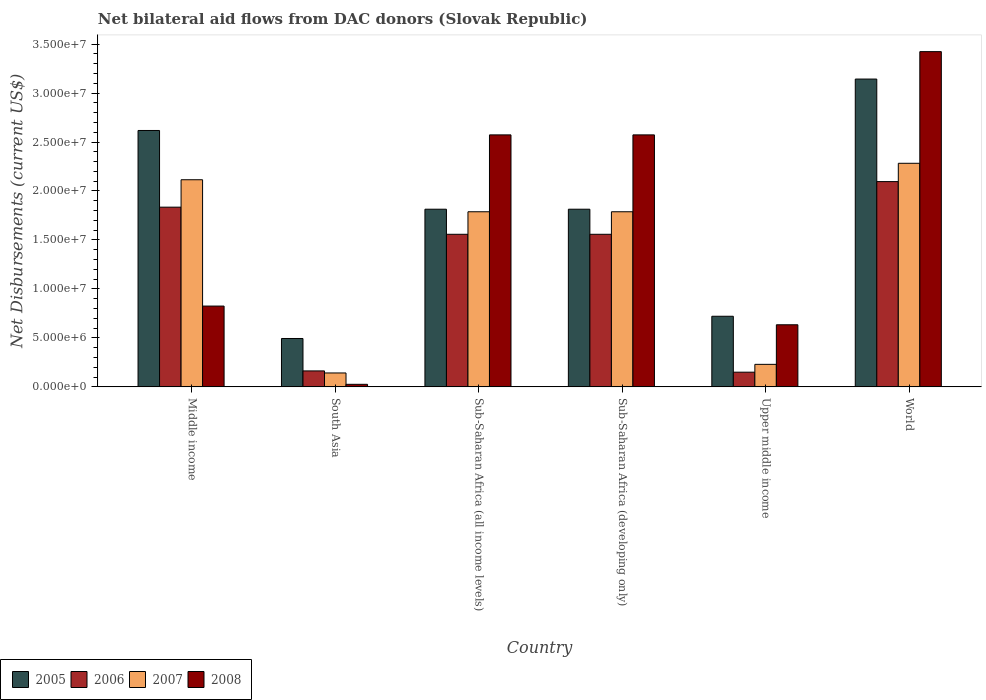How many different coloured bars are there?
Your answer should be compact. 4. How many groups of bars are there?
Your answer should be compact. 6. Are the number of bars per tick equal to the number of legend labels?
Provide a succinct answer. Yes. Are the number of bars on each tick of the X-axis equal?
Give a very brief answer. Yes. How many bars are there on the 1st tick from the left?
Your answer should be compact. 4. What is the label of the 5th group of bars from the left?
Keep it short and to the point. Upper middle income. In how many cases, is the number of bars for a given country not equal to the number of legend labels?
Ensure brevity in your answer.  0. What is the net bilateral aid flows in 2005 in Sub-Saharan Africa (all income levels)?
Keep it short and to the point. 1.81e+07. Across all countries, what is the maximum net bilateral aid flows in 2006?
Your answer should be compact. 2.10e+07. Across all countries, what is the minimum net bilateral aid flows in 2006?
Ensure brevity in your answer.  1.50e+06. In which country was the net bilateral aid flows in 2005 maximum?
Make the answer very short. World. What is the total net bilateral aid flows in 2007 in the graph?
Keep it short and to the point. 8.35e+07. What is the difference between the net bilateral aid flows in 2005 in South Asia and that in World?
Your response must be concise. -2.65e+07. What is the difference between the net bilateral aid flows in 2006 in Sub-Saharan Africa (all income levels) and the net bilateral aid flows in 2007 in World?
Make the answer very short. -7.25e+06. What is the average net bilateral aid flows in 2008 per country?
Offer a very short reply. 1.68e+07. What is the difference between the net bilateral aid flows of/in 2006 and net bilateral aid flows of/in 2005 in Middle income?
Keep it short and to the point. -7.83e+06. What is the ratio of the net bilateral aid flows in 2007 in Sub-Saharan Africa (all income levels) to that in Sub-Saharan Africa (developing only)?
Offer a very short reply. 1. Is the net bilateral aid flows in 2005 in Sub-Saharan Africa (all income levels) less than that in Upper middle income?
Keep it short and to the point. No. Is the difference between the net bilateral aid flows in 2006 in Sub-Saharan Africa (developing only) and Upper middle income greater than the difference between the net bilateral aid flows in 2005 in Sub-Saharan Africa (developing only) and Upper middle income?
Your response must be concise. Yes. What is the difference between the highest and the second highest net bilateral aid flows in 2006?
Keep it short and to the point. 5.38e+06. What is the difference between the highest and the lowest net bilateral aid flows in 2006?
Give a very brief answer. 1.95e+07. In how many countries, is the net bilateral aid flows in 2005 greater than the average net bilateral aid flows in 2005 taken over all countries?
Provide a short and direct response. 4. What does the 2nd bar from the left in Sub-Saharan Africa (developing only) represents?
Give a very brief answer. 2006. What does the 2nd bar from the right in Middle income represents?
Your response must be concise. 2007. Does the graph contain grids?
Your answer should be compact. No. Where does the legend appear in the graph?
Give a very brief answer. Bottom left. How many legend labels are there?
Provide a short and direct response. 4. How are the legend labels stacked?
Offer a terse response. Horizontal. What is the title of the graph?
Your response must be concise. Net bilateral aid flows from DAC donors (Slovak Republic). What is the label or title of the X-axis?
Your answer should be very brief. Country. What is the label or title of the Y-axis?
Offer a terse response. Net Disbursements (current US$). What is the Net Disbursements (current US$) in 2005 in Middle income?
Provide a succinct answer. 2.62e+07. What is the Net Disbursements (current US$) in 2006 in Middle income?
Your answer should be very brief. 1.84e+07. What is the Net Disbursements (current US$) of 2007 in Middle income?
Offer a terse response. 2.12e+07. What is the Net Disbursements (current US$) in 2008 in Middle income?
Give a very brief answer. 8.25e+06. What is the Net Disbursements (current US$) in 2005 in South Asia?
Your answer should be compact. 4.94e+06. What is the Net Disbursements (current US$) in 2006 in South Asia?
Offer a terse response. 1.63e+06. What is the Net Disbursements (current US$) of 2007 in South Asia?
Your response must be concise. 1.42e+06. What is the Net Disbursements (current US$) in 2008 in South Asia?
Provide a succinct answer. 2.60e+05. What is the Net Disbursements (current US$) of 2005 in Sub-Saharan Africa (all income levels)?
Your answer should be compact. 1.81e+07. What is the Net Disbursements (current US$) in 2006 in Sub-Saharan Africa (all income levels)?
Provide a succinct answer. 1.56e+07. What is the Net Disbursements (current US$) in 2007 in Sub-Saharan Africa (all income levels)?
Make the answer very short. 1.79e+07. What is the Net Disbursements (current US$) of 2008 in Sub-Saharan Africa (all income levels)?
Give a very brief answer. 2.57e+07. What is the Net Disbursements (current US$) of 2005 in Sub-Saharan Africa (developing only)?
Your answer should be compact. 1.81e+07. What is the Net Disbursements (current US$) of 2006 in Sub-Saharan Africa (developing only)?
Provide a succinct answer. 1.56e+07. What is the Net Disbursements (current US$) of 2007 in Sub-Saharan Africa (developing only)?
Make the answer very short. 1.79e+07. What is the Net Disbursements (current US$) in 2008 in Sub-Saharan Africa (developing only)?
Give a very brief answer. 2.57e+07. What is the Net Disbursements (current US$) of 2005 in Upper middle income?
Give a very brief answer. 7.21e+06. What is the Net Disbursements (current US$) in 2006 in Upper middle income?
Offer a very short reply. 1.50e+06. What is the Net Disbursements (current US$) of 2007 in Upper middle income?
Offer a very short reply. 2.30e+06. What is the Net Disbursements (current US$) of 2008 in Upper middle income?
Make the answer very short. 6.34e+06. What is the Net Disbursements (current US$) in 2005 in World?
Give a very brief answer. 3.14e+07. What is the Net Disbursements (current US$) in 2006 in World?
Offer a terse response. 2.10e+07. What is the Net Disbursements (current US$) in 2007 in World?
Keep it short and to the point. 2.28e+07. What is the Net Disbursements (current US$) of 2008 in World?
Provide a succinct answer. 3.42e+07. Across all countries, what is the maximum Net Disbursements (current US$) of 2005?
Provide a short and direct response. 3.14e+07. Across all countries, what is the maximum Net Disbursements (current US$) of 2006?
Make the answer very short. 2.10e+07. Across all countries, what is the maximum Net Disbursements (current US$) in 2007?
Your answer should be compact. 2.28e+07. Across all countries, what is the maximum Net Disbursements (current US$) of 2008?
Keep it short and to the point. 3.42e+07. Across all countries, what is the minimum Net Disbursements (current US$) in 2005?
Make the answer very short. 4.94e+06. Across all countries, what is the minimum Net Disbursements (current US$) in 2006?
Offer a terse response. 1.50e+06. Across all countries, what is the minimum Net Disbursements (current US$) in 2007?
Give a very brief answer. 1.42e+06. What is the total Net Disbursements (current US$) in 2005 in the graph?
Keep it short and to the point. 1.06e+08. What is the total Net Disbursements (current US$) of 2006 in the graph?
Your answer should be very brief. 7.36e+07. What is the total Net Disbursements (current US$) in 2007 in the graph?
Offer a terse response. 8.35e+07. What is the total Net Disbursements (current US$) in 2008 in the graph?
Your answer should be compact. 1.01e+08. What is the difference between the Net Disbursements (current US$) in 2005 in Middle income and that in South Asia?
Give a very brief answer. 2.12e+07. What is the difference between the Net Disbursements (current US$) in 2006 in Middle income and that in South Asia?
Keep it short and to the point. 1.67e+07. What is the difference between the Net Disbursements (current US$) of 2007 in Middle income and that in South Asia?
Keep it short and to the point. 1.97e+07. What is the difference between the Net Disbursements (current US$) of 2008 in Middle income and that in South Asia?
Make the answer very short. 7.99e+06. What is the difference between the Net Disbursements (current US$) in 2005 in Middle income and that in Sub-Saharan Africa (all income levels)?
Offer a terse response. 8.04e+06. What is the difference between the Net Disbursements (current US$) of 2006 in Middle income and that in Sub-Saharan Africa (all income levels)?
Offer a terse response. 2.77e+06. What is the difference between the Net Disbursements (current US$) in 2007 in Middle income and that in Sub-Saharan Africa (all income levels)?
Your answer should be very brief. 3.27e+06. What is the difference between the Net Disbursements (current US$) in 2008 in Middle income and that in Sub-Saharan Africa (all income levels)?
Your answer should be compact. -1.75e+07. What is the difference between the Net Disbursements (current US$) of 2005 in Middle income and that in Sub-Saharan Africa (developing only)?
Provide a succinct answer. 8.04e+06. What is the difference between the Net Disbursements (current US$) in 2006 in Middle income and that in Sub-Saharan Africa (developing only)?
Offer a terse response. 2.77e+06. What is the difference between the Net Disbursements (current US$) of 2007 in Middle income and that in Sub-Saharan Africa (developing only)?
Make the answer very short. 3.27e+06. What is the difference between the Net Disbursements (current US$) of 2008 in Middle income and that in Sub-Saharan Africa (developing only)?
Make the answer very short. -1.75e+07. What is the difference between the Net Disbursements (current US$) of 2005 in Middle income and that in Upper middle income?
Provide a short and direct response. 1.90e+07. What is the difference between the Net Disbursements (current US$) of 2006 in Middle income and that in Upper middle income?
Your response must be concise. 1.68e+07. What is the difference between the Net Disbursements (current US$) in 2007 in Middle income and that in Upper middle income?
Your answer should be compact. 1.88e+07. What is the difference between the Net Disbursements (current US$) in 2008 in Middle income and that in Upper middle income?
Offer a very short reply. 1.91e+06. What is the difference between the Net Disbursements (current US$) of 2005 in Middle income and that in World?
Offer a very short reply. -5.25e+06. What is the difference between the Net Disbursements (current US$) of 2006 in Middle income and that in World?
Keep it short and to the point. -2.61e+06. What is the difference between the Net Disbursements (current US$) in 2007 in Middle income and that in World?
Your response must be concise. -1.68e+06. What is the difference between the Net Disbursements (current US$) of 2008 in Middle income and that in World?
Your answer should be compact. -2.60e+07. What is the difference between the Net Disbursements (current US$) of 2005 in South Asia and that in Sub-Saharan Africa (all income levels)?
Your answer should be very brief. -1.32e+07. What is the difference between the Net Disbursements (current US$) of 2006 in South Asia and that in Sub-Saharan Africa (all income levels)?
Give a very brief answer. -1.40e+07. What is the difference between the Net Disbursements (current US$) in 2007 in South Asia and that in Sub-Saharan Africa (all income levels)?
Give a very brief answer. -1.65e+07. What is the difference between the Net Disbursements (current US$) in 2008 in South Asia and that in Sub-Saharan Africa (all income levels)?
Offer a terse response. -2.55e+07. What is the difference between the Net Disbursements (current US$) of 2005 in South Asia and that in Sub-Saharan Africa (developing only)?
Make the answer very short. -1.32e+07. What is the difference between the Net Disbursements (current US$) of 2006 in South Asia and that in Sub-Saharan Africa (developing only)?
Ensure brevity in your answer.  -1.40e+07. What is the difference between the Net Disbursements (current US$) in 2007 in South Asia and that in Sub-Saharan Africa (developing only)?
Make the answer very short. -1.65e+07. What is the difference between the Net Disbursements (current US$) of 2008 in South Asia and that in Sub-Saharan Africa (developing only)?
Your answer should be very brief. -2.55e+07. What is the difference between the Net Disbursements (current US$) of 2005 in South Asia and that in Upper middle income?
Your answer should be very brief. -2.27e+06. What is the difference between the Net Disbursements (current US$) of 2007 in South Asia and that in Upper middle income?
Your answer should be compact. -8.80e+05. What is the difference between the Net Disbursements (current US$) of 2008 in South Asia and that in Upper middle income?
Provide a short and direct response. -6.08e+06. What is the difference between the Net Disbursements (current US$) in 2005 in South Asia and that in World?
Your answer should be very brief. -2.65e+07. What is the difference between the Net Disbursements (current US$) in 2006 in South Asia and that in World?
Give a very brief answer. -1.93e+07. What is the difference between the Net Disbursements (current US$) in 2007 in South Asia and that in World?
Offer a terse response. -2.14e+07. What is the difference between the Net Disbursements (current US$) of 2008 in South Asia and that in World?
Give a very brief answer. -3.40e+07. What is the difference between the Net Disbursements (current US$) of 2005 in Sub-Saharan Africa (all income levels) and that in Sub-Saharan Africa (developing only)?
Make the answer very short. 0. What is the difference between the Net Disbursements (current US$) of 2005 in Sub-Saharan Africa (all income levels) and that in Upper middle income?
Offer a terse response. 1.09e+07. What is the difference between the Net Disbursements (current US$) in 2006 in Sub-Saharan Africa (all income levels) and that in Upper middle income?
Your answer should be compact. 1.41e+07. What is the difference between the Net Disbursements (current US$) in 2007 in Sub-Saharan Africa (all income levels) and that in Upper middle income?
Your answer should be compact. 1.56e+07. What is the difference between the Net Disbursements (current US$) in 2008 in Sub-Saharan Africa (all income levels) and that in Upper middle income?
Provide a succinct answer. 1.94e+07. What is the difference between the Net Disbursements (current US$) of 2005 in Sub-Saharan Africa (all income levels) and that in World?
Your answer should be very brief. -1.33e+07. What is the difference between the Net Disbursements (current US$) of 2006 in Sub-Saharan Africa (all income levels) and that in World?
Your answer should be compact. -5.38e+06. What is the difference between the Net Disbursements (current US$) in 2007 in Sub-Saharan Africa (all income levels) and that in World?
Offer a terse response. -4.95e+06. What is the difference between the Net Disbursements (current US$) in 2008 in Sub-Saharan Africa (all income levels) and that in World?
Offer a very short reply. -8.50e+06. What is the difference between the Net Disbursements (current US$) of 2005 in Sub-Saharan Africa (developing only) and that in Upper middle income?
Provide a short and direct response. 1.09e+07. What is the difference between the Net Disbursements (current US$) in 2006 in Sub-Saharan Africa (developing only) and that in Upper middle income?
Ensure brevity in your answer.  1.41e+07. What is the difference between the Net Disbursements (current US$) in 2007 in Sub-Saharan Africa (developing only) and that in Upper middle income?
Offer a very short reply. 1.56e+07. What is the difference between the Net Disbursements (current US$) of 2008 in Sub-Saharan Africa (developing only) and that in Upper middle income?
Provide a succinct answer. 1.94e+07. What is the difference between the Net Disbursements (current US$) of 2005 in Sub-Saharan Africa (developing only) and that in World?
Your response must be concise. -1.33e+07. What is the difference between the Net Disbursements (current US$) of 2006 in Sub-Saharan Africa (developing only) and that in World?
Keep it short and to the point. -5.38e+06. What is the difference between the Net Disbursements (current US$) of 2007 in Sub-Saharan Africa (developing only) and that in World?
Your answer should be very brief. -4.95e+06. What is the difference between the Net Disbursements (current US$) of 2008 in Sub-Saharan Africa (developing only) and that in World?
Offer a very short reply. -8.50e+06. What is the difference between the Net Disbursements (current US$) in 2005 in Upper middle income and that in World?
Your response must be concise. -2.42e+07. What is the difference between the Net Disbursements (current US$) of 2006 in Upper middle income and that in World?
Provide a short and direct response. -1.95e+07. What is the difference between the Net Disbursements (current US$) in 2007 in Upper middle income and that in World?
Provide a short and direct response. -2.05e+07. What is the difference between the Net Disbursements (current US$) in 2008 in Upper middle income and that in World?
Your answer should be very brief. -2.79e+07. What is the difference between the Net Disbursements (current US$) of 2005 in Middle income and the Net Disbursements (current US$) of 2006 in South Asia?
Provide a succinct answer. 2.46e+07. What is the difference between the Net Disbursements (current US$) in 2005 in Middle income and the Net Disbursements (current US$) in 2007 in South Asia?
Give a very brief answer. 2.48e+07. What is the difference between the Net Disbursements (current US$) of 2005 in Middle income and the Net Disbursements (current US$) of 2008 in South Asia?
Provide a succinct answer. 2.59e+07. What is the difference between the Net Disbursements (current US$) in 2006 in Middle income and the Net Disbursements (current US$) in 2007 in South Asia?
Give a very brief answer. 1.69e+07. What is the difference between the Net Disbursements (current US$) of 2006 in Middle income and the Net Disbursements (current US$) of 2008 in South Asia?
Provide a short and direct response. 1.81e+07. What is the difference between the Net Disbursements (current US$) in 2007 in Middle income and the Net Disbursements (current US$) in 2008 in South Asia?
Provide a succinct answer. 2.09e+07. What is the difference between the Net Disbursements (current US$) in 2005 in Middle income and the Net Disbursements (current US$) in 2006 in Sub-Saharan Africa (all income levels)?
Make the answer very short. 1.06e+07. What is the difference between the Net Disbursements (current US$) in 2005 in Middle income and the Net Disbursements (current US$) in 2007 in Sub-Saharan Africa (all income levels)?
Make the answer very short. 8.30e+06. What is the difference between the Net Disbursements (current US$) of 2006 in Middle income and the Net Disbursements (current US$) of 2007 in Sub-Saharan Africa (all income levels)?
Provide a succinct answer. 4.70e+05. What is the difference between the Net Disbursements (current US$) of 2006 in Middle income and the Net Disbursements (current US$) of 2008 in Sub-Saharan Africa (all income levels)?
Your response must be concise. -7.38e+06. What is the difference between the Net Disbursements (current US$) of 2007 in Middle income and the Net Disbursements (current US$) of 2008 in Sub-Saharan Africa (all income levels)?
Make the answer very short. -4.58e+06. What is the difference between the Net Disbursements (current US$) in 2005 in Middle income and the Net Disbursements (current US$) in 2006 in Sub-Saharan Africa (developing only)?
Make the answer very short. 1.06e+07. What is the difference between the Net Disbursements (current US$) of 2005 in Middle income and the Net Disbursements (current US$) of 2007 in Sub-Saharan Africa (developing only)?
Your answer should be compact. 8.30e+06. What is the difference between the Net Disbursements (current US$) in 2005 in Middle income and the Net Disbursements (current US$) in 2008 in Sub-Saharan Africa (developing only)?
Ensure brevity in your answer.  4.50e+05. What is the difference between the Net Disbursements (current US$) of 2006 in Middle income and the Net Disbursements (current US$) of 2008 in Sub-Saharan Africa (developing only)?
Keep it short and to the point. -7.38e+06. What is the difference between the Net Disbursements (current US$) in 2007 in Middle income and the Net Disbursements (current US$) in 2008 in Sub-Saharan Africa (developing only)?
Offer a terse response. -4.58e+06. What is the difference between the Net Disbursements (current US$) of 2005 in Middle income and the Net Disbursements (current US$) of 2006 in Upper middle income?
Keep it short and to the point. 2.47e+07. What is the difference between the Net Disbursements (current US$) in 2005 in Middle income and the Net Disbursements (current US$) in 2007 in Upper middle income?
Keep it short and to the point. 2.39e+07. What is the difference between the Net Disbursements (current US$) of 2005 in Middle income and the Net Disbursements (current US$) of 2008 in Upper middle income?
Ensure brevity in your answer.  1.98e+07. What is the difference between the Net Disbursements (current US$) in 2006 in Middle income and the Net Disbursements (current US$) in 2007 in Upper middle income?
Your answer should be compact. 1.60e+07. What is the difference between the Net Disbursements (current US$) in 2006 in Middle income and the Net Disbursements (current US$) in 2008 in Upper middle income?
Offer a terse response. 1.20e+07. What is the difference between the Net Disbursements (current US$) in 2007 in Middle income and the Net Disbursements (current US$) in 2008 in Upper middle income?
Ensure brevity in your answer.  1.48e+07. What is the difference between the Net Disbursements (current US$) in 2005 in Middle income and the Net Disbursements (current US$) in 2006 in World?
Offer a very short reply. 5.22e+06. What is the difference between the Net Disbursements (current US$) of 2005 in Middle income and the Net Disbursements (current US$) of 2007 in World?
Give a very brief answer. 3.35e+06. What is the difference between the Net Disbursements (current US$) in 2005 in Middle income and the Net Disbursements (current US$) in 2008 in World?
Ensure brevity in your answer.  -8.05e+06. What is the difference between the Net Disbursements (current US$) in 2006 in Middle income and the Net Disbursements (current US$) in 2007 in World?
Offer a very short reply. -4.48e+06. What is the difference between the Net Disbursements (current US$) in 2006 in Middle income and the Net Disbursements (current US$) in 2008 in World?
Keep it short and to the point. -1.59e+07. What is the difference between the Net Disbursements (current US$) of 2007 in Middle income and the Net Disbursements (current US$) of 2008 in World?
Offer a very short reply. -1.31e+07. What is the difference between the Net Disbursements (current US$) of 2005 in South Asia and the Net Disbursements (current US$) of 2006 in Sub-Saharan Africa (all income levels)?
Your response must be concise. -1.06e+07. What is the difference between the Net Disbursements (current US$) in 2005 in South Asia and the Net Disbursements (current US$) in 2007 in Sub-Saharan Africa (all income levels)?
Make the answer very short. -1.29e+07. What is the difference between the Net Disbursements (current US$) of 2005 in South Asia and the Net Disbursements (current US$) of 2008 in Sub-Saharan Africa (all income levels)?
Your answer should be very brief. -2.08e+07. What is the difference between the Net Disbursements (current US$) of 2006 in South Asia and the Net Disbursements (current US$) of 2007 in Sub-Saharan Africa (all income levels)?
Make the answer very short. -1.62e+07. What is the difference between the Net Disbursements (current US$) in 2006 in South Asia and the Net Disbursements (current US$) in 2008 in Sub-Saharan Africa (all income levels)?
Provide a succinct answer. -2.41e+07. What is the difference between the Net Disbursements (current US$) of 2007 in South Asia and the Net Disbursements (current US$) of 2008 in Sub-Saharan Africa (all income levels)?
Provide a short and direct response. -2.43e+07. What is the difference between the Net Disbursements (current US$) in 2005 in South Asia and the Net Disbursements (current US$) in 2006 in Sub-Saharan Africa (developing only)?
Keep it short and to the point. -1.06e+07. What is the difference between the Net Disbursements (current US$) of 2005 in South Asia and the Net Disbursements (current US$) of 2007 in Sub-Saharan Africa (developing only)?
Your answer should be very brief. -1.29e+07. What is the difference between the Net Disbursements (current US$) of 2005 in South Asia and the Net Disbursements (current US$) of 2008 in Sub-Saharan Africa (developing only)?
Provide a short and direct response. -2.08e+07. What is the difference between the Net Disbursements (current US$) of 2006 in South Asia and the Net Disbursements (current US$) of 2007 in Sub-Saharan Africa (developing only)?
Provide a succinct answer. -1.62e+07. What is the difference between the Net Disbursements (current US$) of 2006 in South Asia and the Net Disbursements (current US$) of 2008 in Sub-Saharan Africa (developing only)?
Keep it short and to the point. -2.41e+07. What is the difference between the Net Disbursements (current US$) in 2007 in South Asia and the Net Disbursements (current US$) in 2008 in Sub-Saharan Africa (developing only)?
Make the answer very short. -2.43e+07. What is the difference between the Net Disbursements (current US$) of 2005 in South Asia and the Net Disbursements (current US$) of 2006 in Upper middle income?
Give a very brief answer. 3.44e+06. What is the difference between the Net Disbursements (current US$) in 2005 in South Asia and the Net Disbursements (current US$) in 2007 in Upper middle income?
Your answer should be compact. 2.64e+06. What is the difference between the Net Disbursements (current US$) in 2005 in South Asia and the Net Disbursements (current US$) in 2008 in Upper middle income?
Your response must be concise. -1.40e+06. What is the difference between the Net Disbursements (current US$) in 2006 in South Asia and the Net Disbursements (current US$) in 2007 in Upper middle income?
Provide a succinct answer. -6.70e+05. What is the difference between the Net Disbursements (current US$) in 2006 in South Asia and the Net Disbursements (current US$) in 2008 in Upper middle income?
Offer a very short reply. -4.71e+06. What is the difference between the Net Disbursements (current US$) of 2007 in South Asia and the Net Disbursements (current US$) of 2008 in Upper middle income?
Keep it short and to the point. -4.92e+06. What is the difference between the Net Disbursements (current US$) in 2005 in South Asia and the Net Disbursements (current US$) in 2006 in World?
Give a very brief answer. -1.60e+07. What is the difference between the Net Disbursements (current US$) in 2005 in South Asia and the Net Disbursements (current US$) in 2007 in World?
Make the answer very short. -1.79e+07. What is the difference between the Net Disbursements (current US$) of 2005 in South Asia and the Net Disbursements (current US$) of 2008 in World?
Your answer should be very brief. -2.93e+07. What is the difference between the Net Disbursements (current US$) in 2006 in South Asia and the Net Disbursements (current US$) in 2007 in World?
Make the answer very short. -2.12e+07. What is the difference between the Net Disbursements (current US$) of 2006 in South Asia and the Net Disbursements (current US$) of 2008 in World?
Offer a very short reply. -3.26e+07. What is the difference between the Net Disbursements (current US$) of 2007 in South Asia and the Net Disbursements (current US$) of 2008 in World?
Give a very brief answer. -3.28e+07. What is the difference between the Net Disbursements (current US$) of 2005 in Sub-Saharan Africa (all income levels) and the Net Disbursements (current US$) of 2006 in Sub-Saharan Africa (developing only)?
Offer a terse response. 2.56e+06. What is the difference between the Net Disbursements (current US$) in 2005 in Sub-Saharan Africa (all income levels) and the Net Disbursements (current US$) in 2008 in Sub-Saharan Africa (developing only)?
Keep it short and to the point. -7.59e+06. What is the difference between the Net Disbursements (current US$) of 2006 in Sub-Saharan Africa (all income levels) and the Net Disbursements (current US$) of 2007 in Sub-Saharan Africa (developing only)?
Offer a terse response. -2.30e+06. What is the difference between the Net Disbursements (current US$) of 2006 in Sub-Saharan Africa (all income levels) and the Net Disbursements (current US$) of 2008 in Sub-Saharan Africa (developing only)?
Keep it short and to the point. -1.02e+07. What is the difference between the Net Disbursements (current US$) in 2007 in Sub-Saharan Africa (all income levels) and the Net Disbursements (current US$) in 2008 in Sub-Saharan Africa (developing only)?
Offer a very short reply. -7.85e+06. What is the difference between the Net Disbursements (current US$) in 2005 in Sub-Saharan Africa (all income levels) and the Net Disbursements (current US$) in 2006 in Upper middle income?
Make the answer very short. 1.66e+07. What is the difference between the Net Disbursements (current US$) in 2005 in Sub-Saharan Africa (all income levels) and the Net Disbursements (current US$) in 2007 in Upper middle income?
Provide a succinct answer. 1.58e+07. What is the difference between the Net Disbursements (current US$) in 2005 in Sub-Saharan Africa (all income levels) and the Net Disbursements (current US$) in 2008 in Upper middle income?
Provide a short and direct response. 1.18e+07. What is the difference between the Net Disbursements (current US$) of 2006 in Sub-Saharan Africa (all income levels) and the Net Disbursements (current US$) of 2007 in Upper middle income?
Your response must be concise. 1.33e+07. What is the difference between the Net Disbursements (current US$) of 2006 in Sub-Saharan Africa (all income levels) and the Net Disbursements (current US$) of 2008 in Upper middle income?
Your response must be concise. 9.24e+06. What is the difference between the Net Disbursements (current US$) of 2007 in Sub-Saharan Africa (all income levels) and the Net Disbursements (current US$) of 2008 in Upper middle income?
Your response must be concise. 1.15e+07. What is the difference between the Net Disbursements (current US$) in 2005 in Sub-Saharan Africa (all income levels) and the Net Disbursements (current US$) in 2006 in World?
Make the answer very short. -2.82e+06. What is the difference between the Net Disbursements (current US$) of 2005 in Sub-Saharan Africa (all income levels) and the Net Disbursements (current US$) of 2007 in World?
Offer a very short reply. -4.69e+06. What is the difference between the Net Disbursements (current US$) in 2005 in Sub-Saharan Africa (all income levels) and the Net Disbursements (current US$) in 2008 in World?
Make the answer very short. -1.61e+07. What is the difference between the Net Disbursements (current US$) of 2006 in Sub-Saharan Africa (all income levels) and the Net Disbursements (current US$) of 2007 in World?
Keep it short and to the point. -7.25e+06. What is the difference between the Net Disbursements (current US$) of 2006 in Sub-Saharan Africa (all income levels) and the Net Disbursements (current US$) of 2008 in World?
Provide a short and direct response. -1.86e+07. What is the difference between the Net Disbursements (current US$) in 2007 in Sub-Saharan Africa (all income levels) and the Net Disbursements (current US$) in 2008 in World?
Your response must be concise. -1.64e+07. What is the difference between the Net Disbursements (current US$) in 2005 in Sub-Saharan Africa (developing only) and the Net Disbursements (current US$) in 2006 in Upper middle income?
Your response must be concise. 1.66e+07. What is the difference between the Net Disbursements (current US$) of 2005 in Sub-Saharan Africa (developing only) and the Net Disbursements (current US$) of 2007 in Upper middle income?
Make the answer very short. 1.58e+07. What is the difference between the Net Disbursements (current US$) of 2005 in Sub-Saharan Africa (developing only) and the Net Disbursements (current US$) of 2008 in Upper middle income?
Offer a very short reply. 1.18e+07. What is the difference between the Net Disbursements (current US$) in 2006 in Sub-Saharan Africa (developing only) and the Net Disbursements (current US$) in 2007 in Upper middle income?
Make the answer very short. 1.33e+07. What is the difference between the Net Disbursements (current US$) in 2006 in Sub-Saharan Africa (developing only) and the Net Disbursements (current US$) in 2008 in Upper middle income?
Provide a succinct answer. 9.24e+06. What is the difference between the Net Disbursements (current US$) of 2007 in Sub-Saharan Africa (developing only) and the Net Disbursements (current US$) of 2008 in Upper middle income?
Your response must be concise. 1.15e+07. What is the difference between the Net Disbursements (current US$) of 2005 in Sub-Saharan Africa (developing only) and the Net Disbursements (current US$) of 2006 in World?
Your answer should be very brief. -2.82e+06. What is the difference between the Net Disbursements (current US$) in 2005 in Sub-Saharan Africa (developing only) and the Net Disbursements (current US$) in 2007 in World?
Your answer should be compact. -4.69e+06. What is the difference between the Net Disbursements (current US$) in 2005 in Sub-Saharan Africa (developing only) and the Net Disbursements (current US$) in 2008 in World?
Offer a terse response. -1.61e+07. What is the difference between the Net Disbursements (current US$) in 2006 in Sub-Saharan Africa (developing only) and the Net Disbursements (current US$) in 2007 in World?
Keep it short and to the point. -7.25e+06. What is the difference between the Net Disbursements (current US$) in 2006 in Sub-Saharan Africa (developing only) and the Net Disbursements (current US$) in 2008 in World?
Provide a succinct answer. -1.86e+07. What is the difference between the Net Disbursements (current US$) in 2007 in Sub-Saharan Africa (developing only) and the Net Disbursements (current US$) in 2008 in World?
Provide a short and direct response. -1.64e+07. What is the difference between the Net Disbursements (current US$) of 2005 in Upper middle income and the Net Disbursements (current US$) of 2006 in World?
Your answer should be very brief. -1.38e+07. What is the difference between the Net Disbursements (current US$) of 2005 in Upper middle income and the Net Disbursements (current US$) of 2007 in World?
Your answer should be compact. -1.56e+07. What is the difference between the Net Disbursements (current US$) in 2005 in Upper middle income and the Net Disbursements (current US$) in 2008 in World?
Your answer should be compact. -2.70e+07. What is the difference between the Net Disbursements (current US$) of 2006 in Upper middle income and the Net Disbursements (current US$) of 2007 in World?
Your answer should be very brief. -2.13e+07. What is the difference between the Net Disbursements (current US$) of 2006 in Upper middle income and the Net Disbursements (current US$) of 2008 in World?
Offer a terse response. -3.27e+07. What is the difference between the Net Disbursements (current US$) in 2007 in Upper middle income and the Net Disbursements (current US$) in 2008 in World?
Offer a very short reply. -3.19e+07. What is the average Net Disbursements (current US$) in 2005 per country?
Make the answer very short. 1.77e+07. What is the average Net Disbursements (current US$) in 2006 per country?
Offer a very short reply. 1.23e+07. What is the average Net Disbursements (current US$) of 2007 per country?
Your answer should be compact. 1.39e+07. What is the average Net Disbursements (current US$) in 2008 per country?
Ensure brevity in your answer.  1.68e+07. What is the difference between the Net Disbursements (current US$) in 2005 and Net Disbursements (current US$) in 2006 in Middle income?
Offer a terse response. 7.83e+06. What is the difference between the Net Disbursements (current US$) in 2005 and Net Disbursements (current US$) in 2007 in Middle income?
Keep it short and to the point. 5.03e+06. What is the difference between the Net Disbursements (current US$) in 2005 and Net Disbursements (current US$) in 2008 in Middle income?
Give a very brief answer. 1.79e+07. What is the difference between the Net Disbursements (current US$) in 2006 and Net Disbursements (current US$) in 2007 in Middle income?
Provide a succinct answer. -2.80e+06. What is the difference between the Net Disbursements (current US$) in 2006 and Net Disbursements (current US$) in 2008 in Middle income?
Offer a terse response. 1.01e+07. What is the difference between the Net Disbursements (current US$) in 2007 and Net Disbursements (current US$) in 2008 in Middle income?
Your response must be concise. 1.29e+07. What is the difference between the Net Disbursements (current US$) in 2005 and Net Disbursements (current US$) in 2006 in South Asia?
Provide a short and direct response. 3.31e+06. What is the difference between the Net Disbursements (current US$) of 2005 and Net Disbursements (current US$) of 2007 in South Asia?
Your answer should be very brief. 3.52e+06. What is the difference between the Net Disbursements (current US$) in 2005 and Net Disbursements (current US$) in 2008 in South Asia?
Provide a succinct answer. 4.68e+06. What is the difference between the Net Disbursements (current US$) of 2006 and Net Disbursements (current US$) of 2007 in South Asia?
Offer a very short reply. 2.10e+05. What is the difference between the Net Disbursements (current US$) in 2006 and Net Disbursements (current US$) in 2008 in South Asia?
Provide a succinct answer. 1.37e+06. What is the difference between the Net Disbursements (current US$) of 2007 and Net Disbursements (current US$) of 2008 in South Asia?
Keep it short and to the point. 1.16e+06. What is the difference between the Net Disbursements (current US$) in 2005 and Net Disbursements (current US$) in 2006 in Sub-Saharan Africa (all income levels)?
Your answer should be very brief. 2.56e+06. What is the difference between the Net Disbursements (current US$) of 2005 and Net Disbursements (current US$) of 2007 in Sub-Saharan Africa (all income levels)?
Provide a short and direct response. 2.60e+05. What is the difference between the Net Disbursements (current US$) of 2005 and Net Disbursements (current US$) of 2008 in Sub-Saharan Africa (all income levels)?
Your answer should be compact. -7.59e+06. What is the difference between the Net Disbursements (current US$) in 2006 and Net Disbursements (current US$) in 2007 in Sub-Saharan Africa (all income levels)?
Make the answer very short. -2.30e+06. What is the difference between the Net Disbursements (current US$) in 2006 and Net Disbursements (current US$) in 2008 in Sub-Saharan Africa (all income levels)?
Give a very brief answer. -1.02e+07. What is the difference between the Net Disbursements (current US$) of 2007 and Net Disbursements (current US$) of 2008 in Sub-Saharan Africa (all income levels)?
Offer a very short reply. -7.85e+06. What is the difference between the Net Disbursements (current US$) in 2005 and Net Disbursements (current US$) in 2006 in Sub-Saharan Africa (developing only)?
Offer a terse response. 2.56e+06. What is the difference between the Net Disbursements (current US$) in 2005 and Net Disbursements (current US$) in 2007 in Sub-Saharan Africa (developing only)?
Offer a terse response. 2.60e+05. What is the difference between the Net Disbursements (current US$) of 2005 and Net Disbursements (current US$) of 2008 in Sub-Saharan Africa (developing only)?
Keep it short and to the point. -7.59e+06. What is the difference between the Net Disbursements (current US$) in 2006 and Net Disbursements (current US$) in 2007 in Sub-Saharan Africa (developing only)?
Make the answer very short. -2.30e+06. What is the difference between the Net Disbursements (current US$) in 2006 and Net Disbursements (current US$) in 2008 in Sub-Saharan Africa (developing only)?
Give a very brief answer. -1.02e+07. What is the difference between the Net Disbursements (current US$) in 2007 and Net Disbursements (current US$) in 2008 in Sub-Saharan Africa (developing only)?
Make the answer very short. -7.85e+06. What is the difference between the Net Disbursements (current US$) of 2005 and Net Disbursements (current US$) of 2006 in Upper middle income?
Make the answer very short. 5.71e+06. What is the difference between the Net Disbursements (current US$) in 2005 and Net Disbursements (current US$) in 2007 in Upper middle income?
Your response must be concise. 4.91e+06. What is the difference between the Net Disbursements (current US$) in 2005 and Net Disbursements (current US$) in 2008 in Upper middle income?
Your answer should be very brief. 8.70e+05. What is the difference between the Net Disbursements (current US$) of 2006 and Net Disbursements (current US$) of 2007 in Upper middle income?
Offer a terse response. -8.00e+05. What is the difference between the Net Disbursements (current US$) in 2006 and Net Disbursements (current US$) in 2008 in Upper middle income?
Provide a short and direct response. -4.84e+06. What is the difference between the Net Disbursements (current US$) of 2007 and Net Disbursements (current US$) of 2008 in Upper middle income?
Keep it short and to the point. -4.04e+06. What is the difference between the Net Disbursements (current US$) of 2005 and Net Disbursements (current US$) of 2006 in World?
Ensure brevity in your answer.  1.05e+07. What is the difference between the Net Disbursements (current US$) of 2005 and Net Disbursements (current US$) of 2007 in World?
Ensure brevity in your answer.  8.60e+06. What is the difference between the Net Disbursements (current US$) of 2005 and Net Disbursements (current US$) of 2008 in World?
Provide a succinct answer. -2.80e+06. What is the difference between the Net Disbursements (current US$) in 2006 and Net Disbursements (current US$) in 2007 in World?
Provide a succinct answer. -1.87e+06. What is the difference between the Net Disbursements (current US$) of 2006 and Net Disbursements (current US$) of 2008 in World?
Your answer should be very brief. -1.33e+07. What is the difference between the Net Disbursements (current US$) of 2007 and Net Disbursements (current US$) of 2008 in World?
Ensure brevity in your answer.  -1.14e+07. What is the ratio of the Net Disbursements (current US$) in 2005 in Middle income to that in South Asia?
Ensure brevity in your answer.  5.3. What is the ratio of the Net Disbursements (current US$) of 2006 in Middle income to that in South Asia?
Give a very brief answer. 11.26. What is the ratio of the Net Disbursements (current US$) of 2007 in Middle income to that in South Asia?
Keep it short and to the point. 14.89. What is the ratio of the Net Disbursements (current US$) of 2008 in Middle income to that in South Asia?
Provide a succinct answer. 31.73. What is the ratio of the Net Disbursements (current US$) in 2005 in Middle income to that in Sub-Saharan Africa (all income levels)?
Provide a short and direct response. 1.44. What is the ratio of the Net Disbursements (current US$) in 2006 in Middle income to that in Sub-Saharan Africa (all income levels)?
Provide a short and direct response. 1.18. What is the ratio of the Net Disbursements (current US$) in 2007 in Middle income to that in Sub-Saharan Africa (all income levels)?
Give a very brief answer. 1.18. What is the ratio of the Net Disbursements (current US$) of 2008 in Middle income to that in Sub-Saharan Africa (all income levels)?
Offer a very short reply. 0.32. What is the ratio of the Net Disbursements (current US$) of 2005 in Middle income to that in Sub-Saharan Africa (developing only)?
Your response must be concise. 1.44. What is the ratio of the Net Disbursements (current US$) of 2006 in Middle income to that in Sub-Saharan Africa (developing only)?
Your answer should be compact. 1.18. What is the ratio of the Net Disbursements (current US$) in 2007 in Middle income to that in Sub-Saharan Africa (developing only)?
Provide a short and direct response. 1.18. What is the ratio of the Net Disbursements (current US$) in 2008 in Middle income to that in Sub-Saharan Africa (developing only)?
Your answer should be compact. 0.32. What is the ratio of the Net Disbursements (current US$) of 2005 in Middle income to that in Upper middle income?
Offer a terse response. 3.63. What is the ratio of the Net Disbursements (current US$) of 2006 in Middle income to that in Upper middle income?
Your response must be concise. 12.23. What is the ratio of the Net Disbursements (current US$) of 2007 in Middle income to that in Upper middle income?
Provide a succinct answer. 9.2. What is the ratio of the Net Disbursements (current US$) of 2008 in Middle income to that in Upper middle income?
Give a very brief answer. 1.3. What is the ratio of the Net Disbursements (current US$) in 2005 in Middle income to that in World?
Provide a short and direct response. 0.83. What is the ratio of the Net Disbursements (current US$) of 2006 in Middle income to that in World?
Provide a succinct answer. 0.88. What is the ratio of the Net Disbursements (current US$) in 2007 in Middle income to that in World?
Provide a succinct answer. 0.93. What is the ratio of the Net Disbursements (current US$) in 2008 in Middle income to that in World?
Offer a terse response. 0.24. What is the ratio of the Net Disbursements (current US$) of 2005 in South Asia to that in Sub-Saharan Africa (all income levels)?
Your answer should be compact. 0.27. What is the ratio of the Net Disbursements (current US$) in 2006 in South Asia to that in Sub-Saharan Africa (all income levels)?
Provide a short and direct response. 0.1. What is the ratio of the Net Disbursements (current US$) of 2007 in South Asia to that in Sub-Saharan Africa (all income levels)?
Make the answer very short. 0.08. What is the ratio of the Net Disbursements (current US$) of 2008 in South Asia to that in Sub-Saharan Africa (all income levels)?
Your answer should be compact. 0.01. What is the ratio of the Net Disbursements (current US$) of 2005 in South Asia to that in Sub-Saharan Africa (developing only)?
Offer a terse response. 0.27. What is the ratio of the Net Disbursements (current US$) of 2006 in South Asia to that in Sub-Saharan Africa (developing only)?
Offer a terse response. 0.1. What is the ratio of the Net Disbursements (current US$) in 2007 in South Asia to that in Sub-Saharan Africa (developing only)?
Provide a succinct answer. 0.08. What is the ratio of the Net Disbursements (current US$) of 2008 in South Asia to that in Sub-Saharan Africa (developing only)?
Offer a very short reply. 0.01. What is the ratio of the Net Disbursements (current US$) in 2005 in South Asia to that in Upper middle income?
Provide a short and direct response. 0.69. What is the ratio of the Net Disbursements (current US$) of 2006 in South Asia to that in Upper middle income?
Ensure brevity in your answer.  1.09. What is the ratio of the Net Disbursements (current US$) in 2007 in South Asia to that in Upper middle income?
Your answer should be very brief. 0.62. What is the ratio of the Net Disbursements (current US$) in 2008 in South Asia to that in Upper middle income?
Keep it short and to the point. 0.04. What is the ratio of the Net Disbursements (current US$) of 2005 in South Asia to that in World?
Offer a very short reply. 0.16. What is the ratio of the Net Disbursements (current US$) in 2006 in South Asia to that in World?
Make the answer very short. 0.08. What is the ratio of the Net Disbursements (current US$) in 2007 in South Asia to that in World?
Offer a very short reply. 0.06. What is the ratio of the Net Disbursements (current US$) of 2008 in South Asia to that in World?
Make the answer very short. 0.01. What is the ratio of the Net Disbursements (current US$) of 2008 in Sub-Saharan Africa (all income levels) to that in Sub-Saharan Africa (developing only)?
Ensure brevity in your answer.  1. What is the ratio of the Net Disbursements (current US$) of 2005 in Sub-Saharan Africa (all income levels) to that in Upper middle income?
Ensure brevity in your answer.  2.52. What is the ratio of the Net Disbursements (current US$) in 2006 in Sub-Saharan Africa (all income levels) to that in Upper middle income?
Make the answer very short. 10.39. What is the ratio of the Net Disbursements (current US$) of 2007 in Sub-Saharan Africa (all income levels) to that in Upper middle income?
Provide a succinct answer. 7.77. What is the ratio of the Net Disbursements (current US$) in 2008 in Sub-Saharan Africa (all income levels) to that in Upper middle income?
Give a very brief answer. 4.06. What is the ratio of the Net Disbursements (current US$) of 2005 in Sub-Saharan Africa (all income levels) to that in World?
Give a very brief answer. 0.58. What is the ratio of the Net Disbursements (current US$) in 2006 in Sub-Saharan Africa (all income levels) to that in World?
Your answer should be very brief. 0.74. What is the ratio of the Net Disbursements (current US$) in 2007 in Sub-Saharan Africa (all income levels) to that in World?
Your response must be concise. 0.78. What is the ratio of the Net Disbursements (current US$) in 2008 in Sub-Saharan Africa (all income levels) to that in World?
Your response must be concise. 0.75. What is the ratio of the Net Disbursements (current US$) of 2005 in Sub-Saharan Africa (developing only) to that in Upper middle income?
Offer a very short reply. 2.52. What is the ratio of the Net Disbursements (current US$) of 2006 in Sub-Saharan Africa (developing only) to that in Upper middle income?
Your answer should be very brief. 10.39. What is the ratio of the Net Disbursements (current US$) of 2007 in Sub-Saharan Africa (developing only) to that in Upper middle income?
Keep it short and to the point. 7.77. What is the ratio of the Net Disbursements (current US$) in 2008 in Sub-Saharan Africa (developing only) to that in Upper middle income?
Give a very brief answer. 4.06. What is the ratio of the Net Disbursements (current US$) in 2005 in Sub-Saharan Africa (developing only) to that in World?
Your answer should be compact. 0.58. What is the ratio of the Net Disbursements (current US$) in 2006 in Sub-Saharan Africa (developing only) to that in World?
Give a very brief answer. 0.74. What is the ratio of the Net Disbursements (current US$) in 2007 in Sub-Saharan Africa (developing only) to that in World?
Offer a very short reply. 0.78. What is the ratio of the Net Disbursements (current US$) in 2008 in Sub-Saharan Africa (developing only) to that in World?
Your answer should be very brief. 0.75. What is the ratio of the Net Disbursements (current US$) in 2005 in Upper middle income to that in World?
Offer a terse response. 0.23. What is the ratio of the Net Disbursements (current US$) in 2006 in Upper middle income to that in World?
Your answer should be compact. 0.07. What is the ratio of the Net Disbursements (current US$) of 2007 in Upper middle income to that in World?
Offer a terse response. 0.1. What is the ratio of the Net Disbursements (current US$) of 2008 in Upper middle income to that in World?
Keep it short and to the point. 0.19. What is the difference between the highest and the second highest Net Disbursements (current US$) of 2005?
Provide a succinct answer. 5.25e+06. What is the difference between the highest and the second highest Net Disbursements (current US$) in 2006?
Offer a very short reply. 2.61e+06. What is the difference between the highest and the second highest Net Disbursements (current US$) of 2007?
Your response must be concise. 1.68e+06. What is the difference between the highest and the second highest Net Disbursements (current US$) of 2008?
Give a very brief answer. 8.50e+06. What is the difference between the highest and the lowest Net Disbursements (current US$) in 2005?
Provide a succinct answer. 2.65e+07. What is the difference between the highest and the lowest Net Disbursements (current US$) of 2006?
Your answer should be very brief. 1.95e+07. What is the difference between the highest and the lowest Net Disbursements (current US$) in 2007?
Your answer should be compact. 2.14e+07. What is the difference between the highest and the lowest Net Disbursements (current US$) in 2008?
Offer a very short reply. 3.40e+07. 